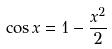<formula> <loc_0><loc_0><loc_500><loc_500>\cos x = 1 - \frac { x ^ { 2 } } { 2 }</formula> 